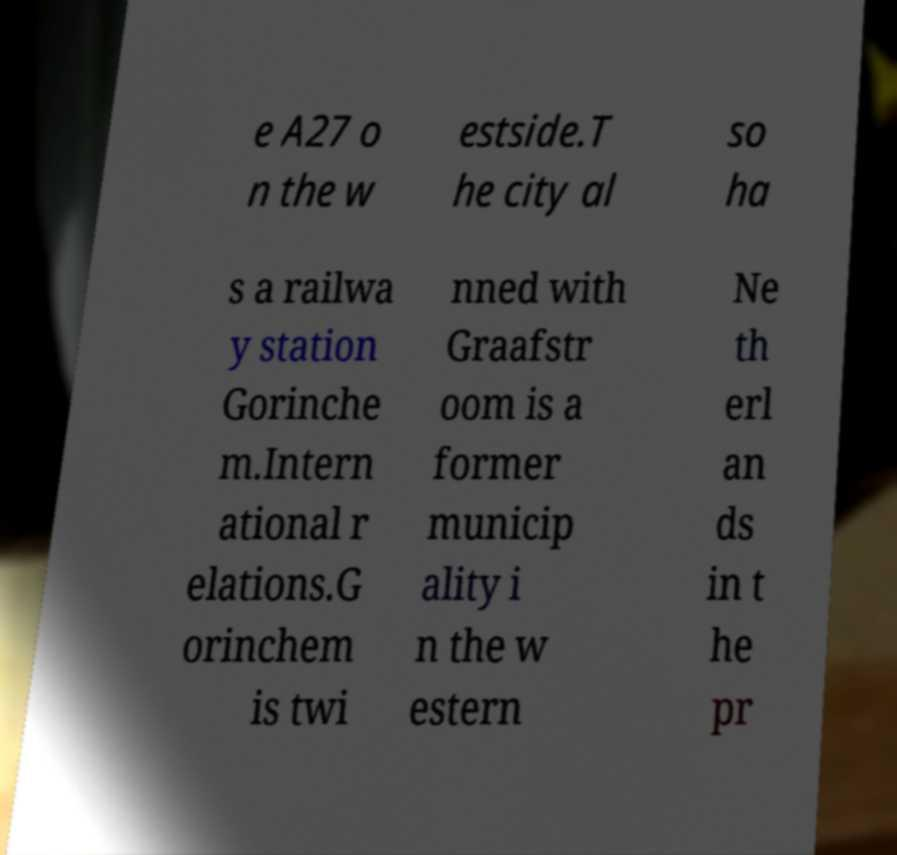Please read and relay the text visible in this image. What does it say? e A27 o n the w estside.T he city al so ha s a railwa y station Gorinche m.Intern ational r elations.G orinchem is twi nned with Graafstr oom is a former municip ality i n the w estern Ne th erl an ds in t he pr 